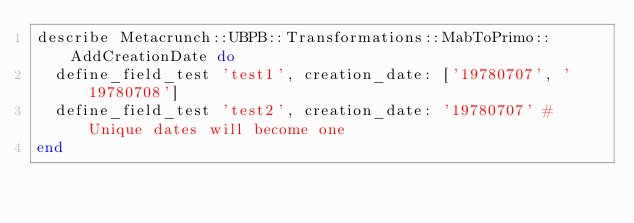Convert code to text. <code><loc_0><loc_0><loc_500><loc_500><_Ruby_>describe Metacrunch::UBPB::Transformations::MabToPrimo::AddCreationDate do
  define_field_test 'test1', creation_date: ['19780707', '19780708']
  define_field_test 'test2', creation_date: '19780707' # Unique dates will become one
end
</code> 